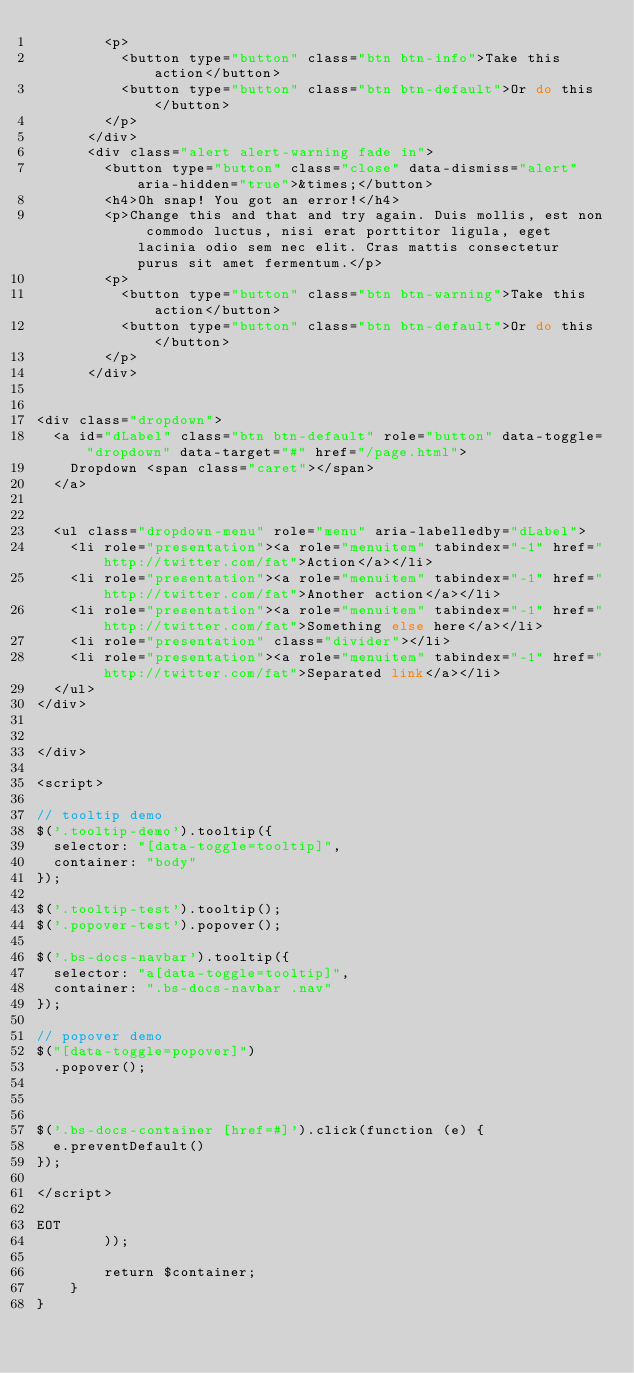Convert code to text. <code><loc_0><loc_0><loc_500><loc_500><_PHP_>        <p>
          <button type="button" class="btn btn-info">Take this action</button>
          <button type="button" class="btn btn-default">Or do this</button>
        </p>
      </div>
      <div class="alert alert-warning fade in">
        <button type="button" class="close" data-dismiss="alert" aria-hidden="true">&times;</button>
        <h4>Oh snap! You got an error!</h4>
        <p>Change this and that and try again. Duis mollis, est non commodo luctus, nisi erat porttitor ligula, eget lacinia odio sem nec elit. Cras mattis consectetur purus sit amet fermentum.</p>
        <p>
          <button type="button" class="btn btn-warning">Take this action</button>
          <button type="button" class="btn btn-default">Or do this</button>
        </p>
      </div>


<div class="dropdown">
  <a id="dLabel" class="btn btn-default" role="button" data-toggle="dropdown" data-target="#" href="/page.html">
    Dropdown <span class="caret"></span>
  </a>


  <ul class="dropdown-menu" role="menu" aria-labelledby="dLabel">
    <li role="presentation"><a role="menuitem" tabindex="-1" href="http://twitter.com/fat">Action</a></li>
    <li role="presentation"><a role="menuitem" tabindex="-1" href="http://twitter.com/fat">Another action</a></li>
    <li role="presentation"><a role="menuitem" tabindex="-1" href="http://twitter.com/fat">Something else here</a></li>
    <li role="presentation" class="divider"></li>
    <li role="presentation"><a role="menuitem" tabindex="-1" href="http://twitter.com/fat">Separated link</a></li>
  </ul>
</div>


</div>

<script>

// tooltip demo
$('.tooltip-demo').tooltip({
  selector: "[data-toggle=tooltip]",
  container: "body"
});

$('.tooltip-test').tooltip();
$('.popover-test').popover();

$('.bs-docs-navbar').tooltip({
  selector: "a[data-toggle=tooltip]",
  container: ".bs-docs-navbar .nav"
});

// popover demo
$("[data-toggle=popover]")
  .popover();



$('.bs-docs-container [href=#]').click(function (e) {
  e.preventDefault()
});

</script>

EOT
        ));

        return $container;
    }
}
</code> 